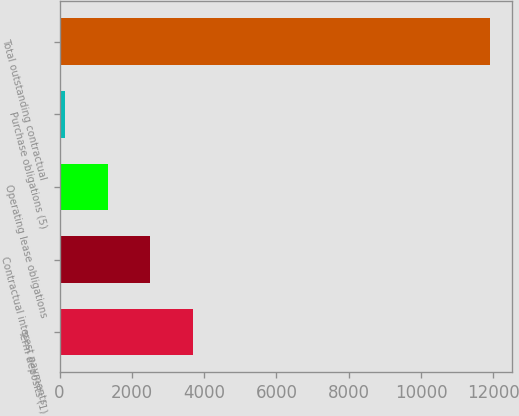Convert chart to OTSL. <chart><loc_0><loc_0><loc_500><loc_500><bar_chart><fcel>Term deposits (1)<fcel>Contractual interest payments<fcel>Operating lease obligations<fcel>Purchase obligations (5)<fcel>Total outstanding contractual<nl><fcel>3680.5<fcel>2505<fcel>1329.5<fcel>154<fcel>11909<nl></chart> 